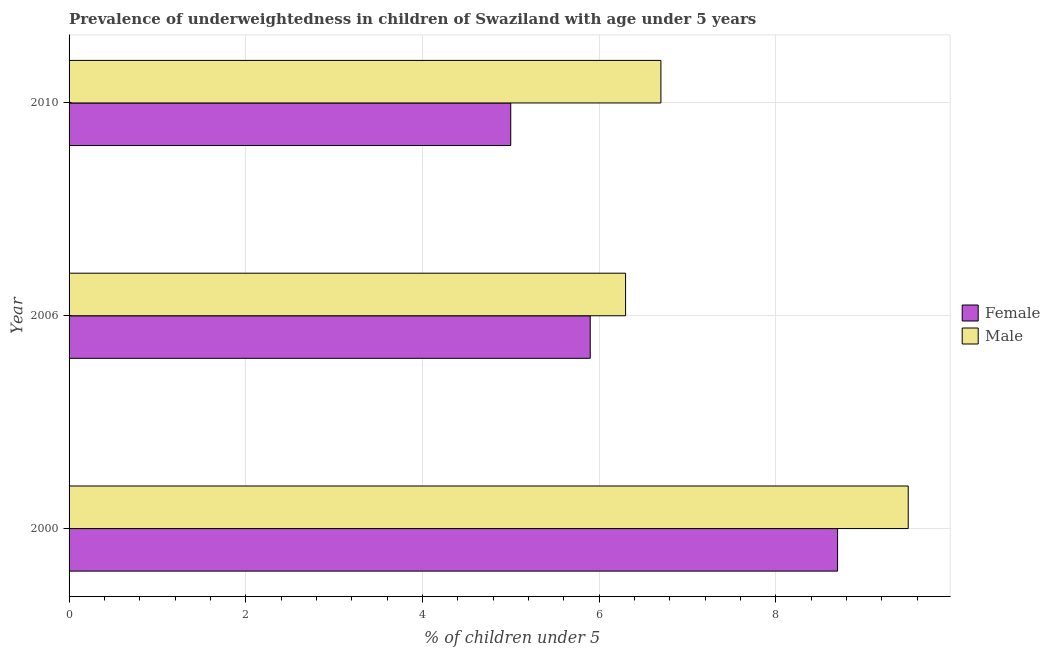How many different coloured bars are there?
Your answer should be compact. 2. How many groups of bars are there?
Provide a short and direct response. 3. Are the number of bars on each tick of the Y-axis equal?
Offer a terse response. Yes. How many bars are there on the 1st tick from the top?
Provide a succinct answer. 2. What is the label of the 2nd group of bars from the top?
Make the answer very short. 2006. What is the percentage of underweighted female children in 2010?
Give a very brief answer. 5. Across all years, what is the maximum percentage of underweighted male children?
Ensure brevity in your answer.  9.5. In which year was the percentage of underweighted male children maximum?
Give a very brief answer. 2000. What is the total percentage of underweighted male children in the graph?
Ensure brevity in your answer.  22.5. What is the difference between the percentage of underweighted male children in 2000 and that in 2010?
Your response must be concise. 2.8. What is the difference between the percentage of underweighted male children in 2010 and the percentage of underweighted female children in 2006?
Offer a terse response. 0.8. What is the average percentage of underweighted female children per year?
Your answer should be very brief. 6.53. In the year 2006, what is the difference between the percentage of underweighted female children and percentage of underweighted male children?
Provide a succinct answer. -0.4. What is the ratio of the percentage of underweighted male children in 2000 to that in 2010?
Make the answer very short. 1.42. What is the difference between the highest and the second highest percentage of underweighted male children?
Provide a short and direct response. 2.8. Is the sum of the percentage of underweighted male children in 2000 and 2006 greater than the maximum percentage of underweighted female children across all years?
Offer a very short reply. Yes. What does the 1st bar from the top in 2006 represents?
Offer a terse response. Male. What is the difference between two consecutive major ticks on the X-axis?
Offer a terse response. 2. Are the values on the major ticks of X-axis written in scientific E-notation?
Your answer should be very brief. No. Does the graph contain grids?
Provide a succinct answer. Yes. Where does the legend appear in the graph?
Give a very brief answer. Center right. How many legend labels are there?
Keep it short and to the point. 2. How are the legend labels stacked?
Offer a very short reply. Vertical. What is the title of the graph?
Your response must be concise. Prevalence of underweightedness in children of Swaziland with age under 5 years. Does "From Government" appear as one of the legend labels in the graph?
Provide a succinct answer. No. What is the label or title of the X-axis?
Your answer should be compact.  % of children under 5. What is the  % of children under 5 in Female in 2000?
Your answer should be compact. 8.7. What is the  % of children under 5 in Male in 2000?
Offer a very short reply. 9.5. What is the  % of children under 5 in Female in 2006?
Ensure brevity in your answer.  5.9. What is the  % of children under 5 of Male in 2006?
Make the answer very short. 6.3. What is the  % of children under 5 in Female in 2010?
Provide a short and direct response. 5. What is the  % of children under 5 of Male in 2010?
Your answer should be very brief. 6.7. Across all years, what is the maximum  % of children under 5 of Female?
Offer a very short reply. 8.7. Across all years, what is the minimum  % of children under 5 of Female?
Make the answer very short. 5. Across all years, what is the minimum  % of children under 5 of Male?
Offer a terse response. 6.3. What is the total  % of children under 5 in Female in the graph?
Keep it short and to the point. 19.6. What is the difference between the  % of children under 5 in Male in 2000 and that in 2010?
Make the answer very short. 2.8. What is the difference between the  % of children under 5 in Female in 2006 and that in 2010?
Offer a very short reply. 0.9. What is the difference between the  % of children under 5 of Female in 2000 and the  % of children under 5 of Male in 2010?
Provide a short and direct response. 2. What is the difference between the  % of children under 5 of Female in 2006 and the  % of children under 5 of Male in 2010?
Your answer should be very brief. -0.8. What is the average  % of children under 5 of Female per year?
Provide a short and direct response. 6.53. What is the average  % of children under 5 of Male per year?
Your answer should be compact. 7.5. In the year 2006, what is the difference between the  % of children under 5 of Female and  % of children under 5 of Male?
Ensure brevity in your answer.  -0.4. In the year 2010, what is the difference between the  % of children under 5 of Female and  % of children under 5 of Male?
Give a very brief answer. -1.7. What is the ratio of the  % of children under 5 in Female in 2000 to that in 2006?
Your answer should be compact. 1.47. What is the ratio of the  % of children under 5 of Male in 2000 to that in 2006?
Your answer should be very brief. 1.51. What is the ratio of the  % of children under 5 in Female in 2000 to that in 2010?
Give a very brief answer. 1.74. What is the ratio of the  % of children under 5 in Male in 2000 to that in 2010?
Give a very brief answer. 1.42. What is the ratio of the  % of children under 5 of Female in 2006 to that in 2010?
Provide a succinct answer. 1.18. What is the ratio of the  % of children under 5 in Male in 2006 to that in 2010?
Provide a short and direct response. 0.94. What is the difference between the highest and the lowest  % of children under 5 in Male?
Ensure brevity in your answer.  3.2. 